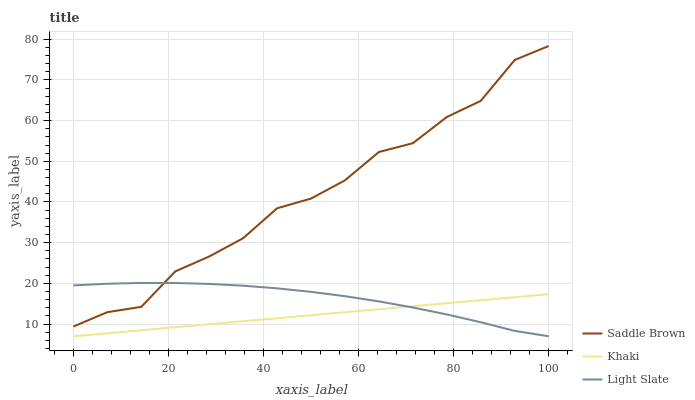Does Khaki have the minimum area under the curve?
Answer yes or no. Yes. Does Saddle Brown have the maximum area under the curve?
Answer yes or no. Yes. Does Saddle Brown have the minimum area under the curve?
Answer yes or no. No. Does Khaki have the maximum area under the curve?
Answer yes or no. No. Is Khaki the smoothest?
Answer yes or no. Yes. Is Saddle Brown the roughest?
Answer yes or no. Yes. Is Saddle Brown the smoothest?
Answer yes or no. No. Is Khaki the roughest?
Answer yes or no. No. Does Light Slate have the lowest value?
Answer yes or no. Yes. Does Saddle Brown have the lowest value?
Answer yes or no. No. Does Saddle Brown have the highest value?
Answer yes or no. Yes. Does Khaki have the highest value?
Answer yes or no. No. Is Khaki less than Saddle Brown?
Answer yes or no. Yes. Is Saddle Brown greater than Khaki?
Answer yes or no. Yes. Does Light Slate intersect Khaki?
Answer yes or no. Yes. Is Light Slate less than Khaki?
Answer yes or no. No. Is Light Slate greater than Khaki?
Answer yes or no. No. Does Khaki intersect Saddle Brown?
Answer yes or no. No. 